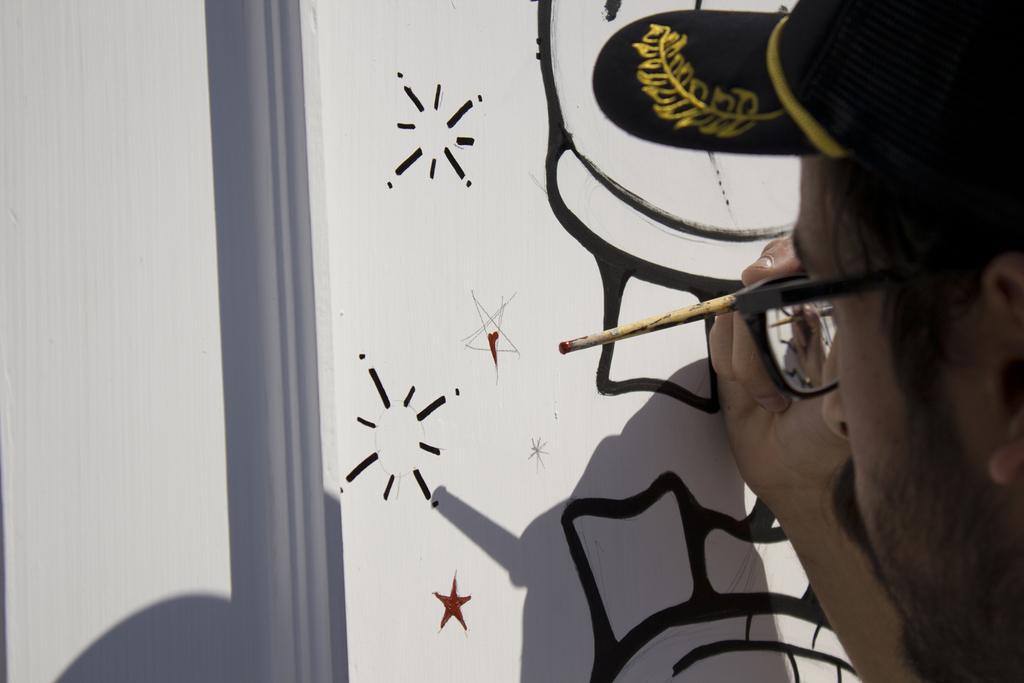Could you give a brief overview of what you see in this image? In this image I can see a man is holding a paint brush in the hand. The man is wearing a hat and spectacles. Here I can see a painting on a white color surface. 